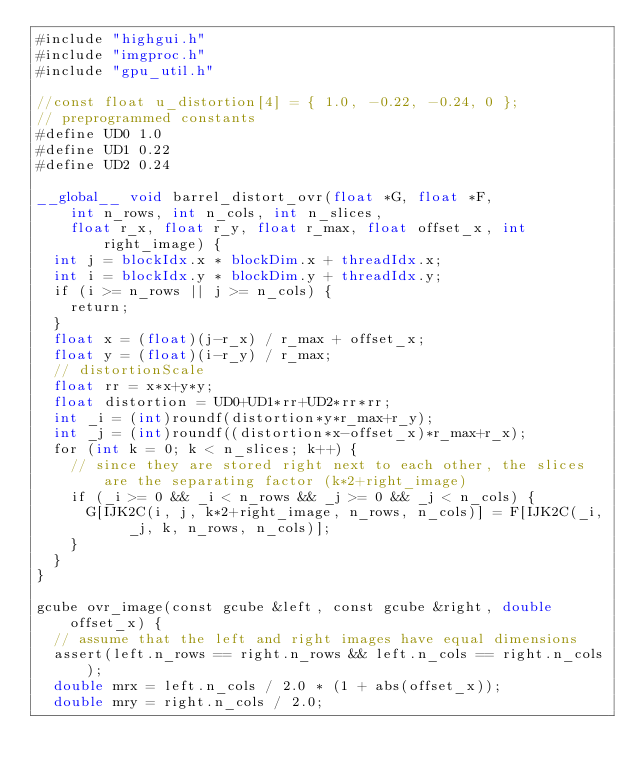<code> <loc_0><loc_0><loc_500><loc_500><_Cuda_>#include "highgui.h"
#include "imgproc.h"
#include "gpu_util.h"

//const float u_distortion[4] = { 1.0, -0.22, -0.24, 0 };
// preprogrammed constants
#define UD0 1.0
#define UD1 0.22
#define UD2 0.24

__global__ void barrel_distort_ovr(float *G, float *F,
    int n_rows, int n_cols, int n_slices,
    float r_x, float r_y, float r_max, float offset_x, int right_image) {
  int j = blockIdx.x * blockDim.x + threadIdx.x;
  int i = blockIdx.y * blockDim.y + threadIdx.y;
  if (i >= n_rows || j >= n_cols) {
    return;
  }
  float x = (float)(j-r_x) / r_max + offset_x;
  float y = (float)(i-r_y) / r_max;
  // distortionScale
  float rr = x*x+y*y;
  float distortion = UD0+UD1*rr+UD2*rr*rr;
  int _i = (int)roundf(distortion*y*r_max+r_y);
  int _j = (int)roundf((distortion*x-offset_x)*r_max+r_x);
  for (int k = 0; k < n_slices; k++) {
    // since they are stored right next to each other, the slices are the separating factor (k*2+right_image)
    if (_i >= 0 && _i < n_rows && _j >= 0 && _j < n_cols) {
      G[IJK2C(i, j, k*2+right_image, n_rows, n_cols)] = F[IJK2C(_i, _j, k, n_rows, n_cols)];
    }
  }
}

gcube ovr_image(const gcube &left, const gcube &right, double offset_x) {
  // assume that the left and right images have equal dimensions
  assert(left.n_rows == right.n_rows && left.n_cols == right.n_cols);
  double mrx = left.n_cols / 2.0 * (1 + abs(offset_x));
  double mry = right.n_cols / 2.0;</code> 